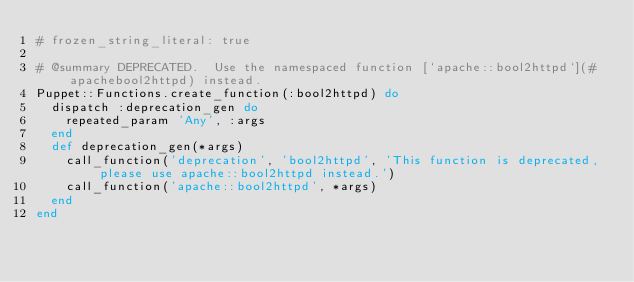<code> <loc_0><loc_0><loc_500><loc_500><_Ruby_># frozen_string_literal: true

# @summary DEPRECATED.  Use the namespaced function [`apache::bool2httpd`](#apachebool2httpd) instead.
Puppet::Functions.create_function(:bool2httpd) do
  dispatch :deprecation_gen do
    repeated_param 'Any', :args
  end
  def deprecation_gen(*args)
    call_function('deprecation', 'bool2httpd', 'This function is deprecated, please use apache::bool2httpd instead.')
    call_function('apache::bool2httpd', *args)
  end
end
</code> 